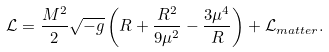Convert formula to latex. <formula><loc_0><loc_0><loc_500><loc_500>\mathcal { L } = \frac { M ^ { 2 } } { 2 } \sqrt { - g } \left ( R + \frac { R ^ { 2 } } { 9 \mu ^ { 2 } } - \frac { 3 \mu ^ { 4 } } { R } \right ) + \mathcal { L } _ { m a t t e r } .</formula> 